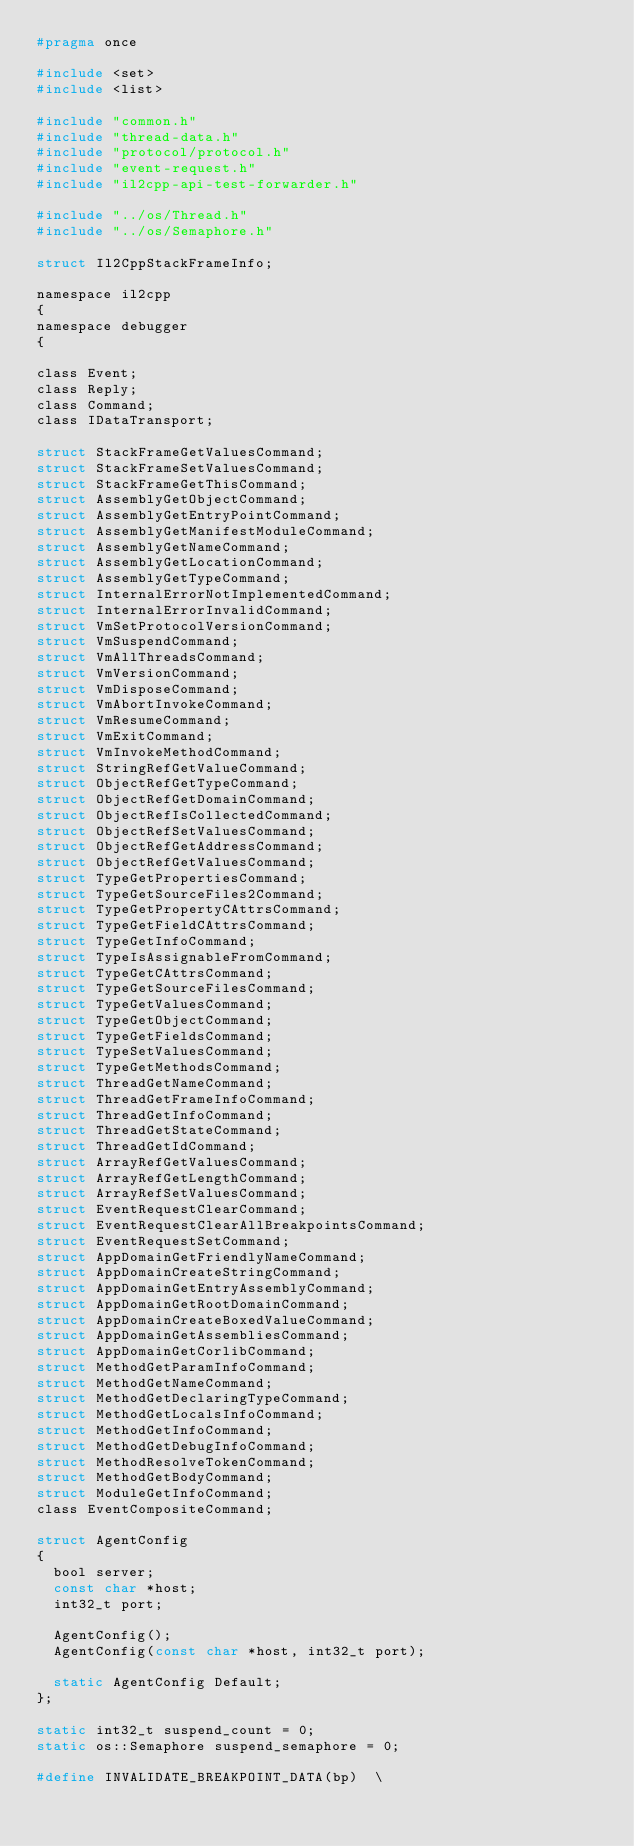<code> <loc_0><loc_0><loc_500><loc_500><_C_>#pragma once

#include <set>
#include <list>

#include "common.h"
#include "thread-data.h"
#include "protocol/protocol.h"
#include "event-request.h"
#include "il2cpp-api-test-forwarder.h"

#include "../os/Thread.h"
#include "../os/Semaphore.h"

struct Il2CppStackFrameInfo;

namespace il2cpp
{
namespace debugger
{

class Event;
class Reply;
class Command;
class IDataTransport;

struct StackFrameGetValuesCommand;
struct StackFrameSetValuesCommand;
struct StackFrameGetThisCommand;
struct AssemblyGetObjectCommand;
struct AssemblyGetEntryPointCommand;
struct AssemblyGetManifestModuleCommand;
struct AssemblyGetNameCommand;
struct AssemblyGetLocationCommand;
struct AssemblyGetTypeCommand;
struct InternalErrorNotImplementedCommand;
struct InternalErrorInvalidCommand;
struct VmSetProtocolVersionCommand;
struct VmSuspendCommand;
struct VmAllThreadsCommand;
struct VmVersionCommand;
struct VmDisposeCommand;
struct VmAbortInvokeCommand;
struct VmResumeCommand;
struct VmExitCommand;
struct VmInvokeMethodCommand;
struct StringRefGetValueCommand;
struct ObjectRefGetTypeCommand;
struct ObjectRefGetDomainCommand;
struct ObjectRefIsCollectedCommand;
struct ObjectRefSetValuesCommand;
struct ObjectRefGetAddressCommand;
struct ObjectRefGetValuesCommand;
struct TypeGetPropertiesCommand;
struct TypeGetSourceFiles2Command;
struct TypeGetPropertyCAttrsCommand;
struct TypeGetFieldCAttrsCommand;
struct TypeGetInfoCommand;
struct TypeIsAssignableFromCommand;
struct TypeGetCAttrsCommand;
struct TypeGetSourceFilesCommand;
struct TypeGetValuesCommand;
struct TypeGetObjectCommand;
struct TypeGetFieldsCommand;
struct TypeSetValuesCommand;
struct TypeGetMethodsCommand;
struct ThreadGetNameCommand;
struct ThreadGetFrameInfoCommand;
struct ThreadGetInfoCommand;
struct ThreadGetStateCommand;
struct ThreadGetIdCommand;
struct ArrayRefGetValuesCommand;
struct ArrayRefGetLengthCommand;
struct ArrayRefSetValuesCommand;
struct EventRequestClearCommand;
struct EventRequestClearAllBreakpointsCommand;
struct EventRequestSetCommand;
struct AppDomainGetFriendlyNameCommand;
struct AppDomainCreateStringCommand;
struct AppDomainGetEntryAssemblyCommand;
struct AppDomainGetRootDomainCommand;
struct AppDomainCreateBoxedValueCommand;
struct AppDomainGetAssembliesCommand;
struct AppDomainGetCorlibCommand;
struct MethodGetParamInfoCommand;
struct MethodGetNameCommand;
struct MethodGetDeclaringTypeCommand;
struct MethodGetLocalsInfoCommand;
struct MethodGetInfoCommand;
struct MethodGetDebugInfoCommand;
struct MethodResolveTokenCommand;
struct MethodGetBodyCommand;
struct ModuleGetInfoCommand;
class EventCompositeCommand;

struct AgentConfig
{
	bool server;
	const char *host;
	int32_t port;

	AgentConfig();
	AgentConfig(const char *host, int32_t port);

	static AgentConfig Default;
};

static int32_t suspend_count = 0;
static os::Semaphore suspend_semaphore = 0;

#define INVALIDATE_BREAKPOINT_DATA(bp)	\</code> 